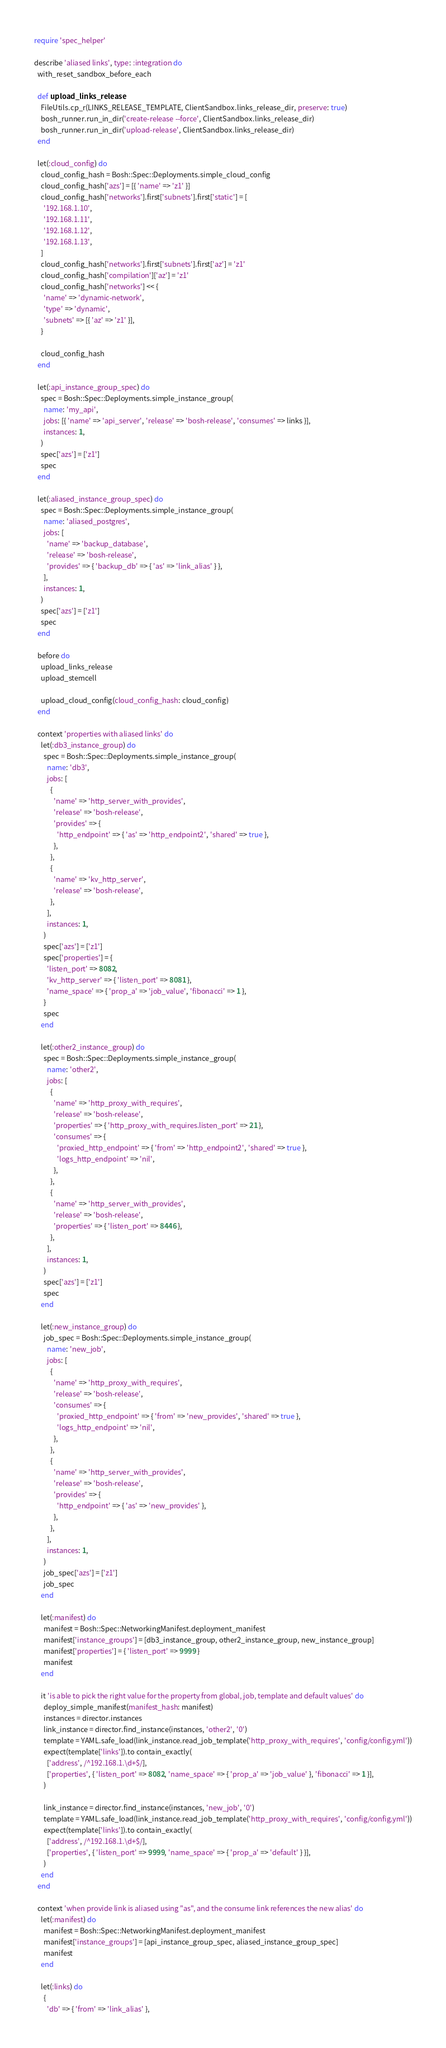Convert code to text. <code><loc_0><loc_0><loc_500><loc_500><_Ruby_>require 'spec_helper'

describe 'aliased links', type: :integration do
  with_reset_sandbox_before_each

  def upload_links_release
    FileUtils.cp_r(LINKS_RELEASE_TEMPLATE, ClientSandbox.links_release_dir, preserve: true)
    bosh_runner.run_in_dir('create-release --force', ClientSandbox.links_release_dir)
    bosh_runner.run_in_dir('upload-release', ClientSandbox.links_release_dir)
  end

  let(:cloud_config) do
    cloud_config_hash = Bosh::Spec::Deployments.simple_cloud_config
    cloud_config_hash['azs'] = [{ 'name' => 'z1' }]
    cloud_config_hash['networks'].first['subnets'].first['static'] = [
      '192.168.1.10',
      '192.168.1.11',
      '192.168.1.12',
      '192.168.1.13',
    ]
    cloud_config_hash['networks'].first['subnets'].first['az'] = 'z1'
    cloud_config_hash['compilation']['az'] = 'z1'
    cloud_config_hash['networks'] << {
      'name' => 'dynamic-network',
      'type' => 'dynamic',
      'subnets' => [{ 'az' => 'z1' }],
    }

    cloud_config_hash
  end

  let(:api_instance_group_spec) do
    spec = Bosh::Spec::Deployments.simple_instance_group(
      name: 'my_api',
      jobs: [{ 'name' => 'api_server', 'release' => 'bosh-release', 'consumes' => links }],
      instances: 1,
    )
    spec['azs'] = ['z1']
    spec
  end

  let(:aliased_instance_group_spec) do
    spec = Bosh::Spec::Deployments.simple_instance_group(
      name: 'aliased_postgres',
      jobs: [
        'name' => 'backup_database',
        'release' => 'bosh-release',
        'provides' => { 'backup_db' => { 'as' => 'link_alias' } },
      ],
      instances: 1,
    )
    spec['azs'] = ['z1']
    spec
  end

  before do
    upload_links_release
    upload_stemcell

    upload_cloud_config(cloud_config_hash: cloud_config)
  end

  context 'properties with aliased links' do
    let(:db3_instance_group) do
      spec = Bosh::Spec::Deployments.simple_instance_group(
        name: 'db3',
        jobs: [
          {
            'name' => 'http_server_with_provides',
            'release' => 'bosh-release',
            'provides' => {
              'http_endpoint' => { 'as' => 'http_endpoint2', 'shared' => true },
            },
          },
          {
            'name' => 'kv_http_server',
            'release' => 'bosh-release',
          },
        ],
        instances: 1,
      )
      spec['azs'] = ['z1']
      spec['properties'] = {
        'listen_port' => 8082,
        'kv_http_server' => { 'listen_port' => 8081 },
        'name_space' => { 'prop_a' => 'job_value', 'fibonacci' => 1 },
      }
      spec
    end

    let(:other2_instance_group) do
      spec = Bosh::Spec::Deployments.simple_instance_group(
        name: 'other2',
        jobs: [
          {
            'name' => 'http_proxy_with_requires',
            'release' => 'bosh-release',
            'properties' => { 'http_proxy_with_requires.listen_port' => 21 },
            'consumes' => {
              'proxied_http_endpoint' => { 'from' => 'http_endpoint2', 'shared' => true },
              'logs_http_endpoint' => 'nil',
            },
          },
          {
            'name' => 'http_server_with_provides',
            'release' => 'bosh-release',
            'properties' => { 'listen_port' => 8446 },
          },
        ],
        instances: 1,
      )
      spec['azs'] = ['z1']
      spec
    end

    let(:new_instance_group) do
      job_spec = Bosh::Spec::Deployments.simple_instance_group(
        name: 'new_job',
        jobs: [
          {
            'name' => 'http_proxy_with_requires',
            'release' => 'bosh-release',
            'consumes' => {
              'proxied_http_endpoint' => { 'from' => 'new_provides', 'shared' => true },
              'logs_http_endpoint' => 'nil',
            },
          },
          {
            'name' => 'http_server_with_provides',
            'release' => 'bosh-release',
            'provides' => {
              'http_endpoint' => { 'as' => 'new_provides' },
            },
          },
        ],
        instances: 1,
      )
      job_spec['azs'] = ['z1']
      job_spec
    end

    let(:manifest) do
      manifest = Bosh::Spec::NetworkingManifest.deployment_manifest
      manifest['instance_groups'] = [db3_instance_group, other2_instance_group, new_instance_group]
      manifest['properties'] = { 'listen_port' => 9999 }
      manifest
    end

    it 'is able to pick the right value for the property from global, job, template and default values' do
      deploy_simple_manifest(manifest_hash: manifest)
      instances = director.instances
      link_instance = director.find_instance(instances, 'other2', '0')
      template = YAML.safe_load(link_instance.read_job_template('http_proxy_with_requires', 'config/config.yml'))
      expect(template['links']).to contain_exactly(
        ['address', /^192.168.1.\d+$/],
        ['properties', { 'listen_port' => 8082, 'name_space' => { 'prop_a' => 'job_value' }, 'fibonacci' => 1 }],
      )

      link_instance = director.find_instance(instances, 'new_job', '0')
      template = YAML.safe_load(link_instance.read_job_template('http_proxy_with_requires', 'config/config.yml'))
      expect(template['links']).to contain_exactly(
        ['address', /^192.168.1.\d+$/],
        ['properties', { 'listen_port' => 9999, 'name_space' => { 'prop_a' => 'default' } }],
      )
    end
  end

  context 'when provide link is aliased using "as", and the consume link references the new alias' do
    let(:manifest) do
      manifest = Bosh::Spec::NetworkingManifest.deployment_manifest
      manifest['instance_groups'] = [api_instance_group_spec, aliased_instance_group_spec]
      manifest
    end

    let(:links) do
      {
        'db' => { 'from' => 'link_alias' },</code> 